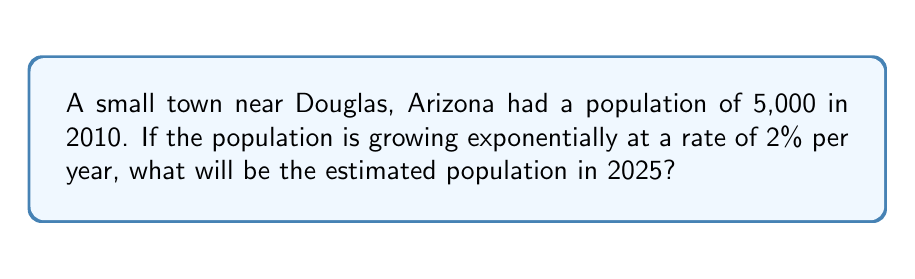What is the answer to this math problem? To solve this problem, we'll use the exponential growth formula:

$$A = P(1 + r)^t$$

Where:
$A$ = Final amount (population in 2025)
$P$ = Initial amount (population in 2010)
$r$ = Growth rate (as a decimal)
$t$ = Time period (in years)

Given:
$P = 5,000$
$r = 2\% = 0.02$
$t = 2025 - 2010 = 15$ years

Let's plug these values into the formula:

$$A = 5,000(1 + 0.02)^{15}$$

Now, let's calculate step-by-step:

1) First, calculate $(1 + 0.02)$:
   $1 + 0.02 = 1.02$

2) Now, raise 1.02 to the power of 15:
   $1.02^{15} \approx 1.3459$ (rounded to 4 decimal places)

3) Finally, multiply this by the initial population:
   $5,000 \times 1.3459 \approx 6,729.5$

4) Round to the nearest whole number, as we're dealing with people:
   $6,730$ people

Therefore, the estimated population of the town in 2025 will be approximately 6,730 people.
Answer: 6,730 people 